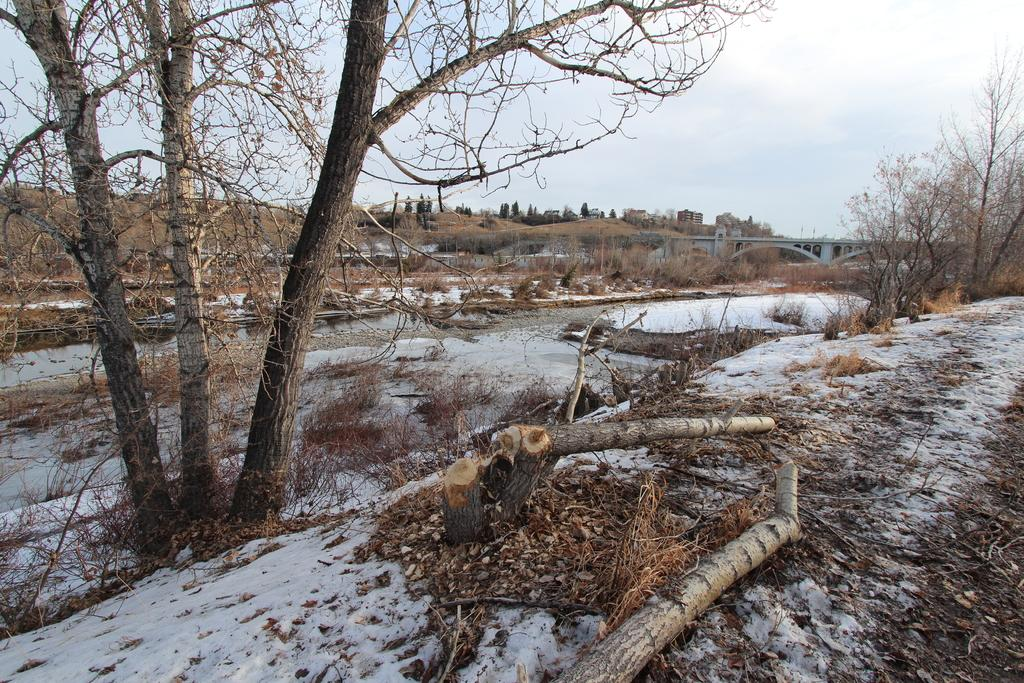What can be seen on the right side of the image? There are tree trunks and trees on the right side of the image. What is the weather condition in the image? There is snow visible in the image, indicating a cold or wintery condition. What is located in the background of the image? There is a bridge and trees in the background of the image. What type of apparel is the tree wearing in the image? Trees do not wear apparel, so this question cannot be answered. Can you see anyone smashing the snow in the image? There is no indication of anyone smashing the snow in the image. 